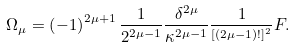<formula> <loc_0><loc_0><loc_500><loc_500>\Omega _ { \mu } = \left ( - 1 \right ) ^ { 2 \mu + 1 } \frac { 1 } { 2 ^ { 2 \mu - 1 } } \frac { \delta ^ { 2 \mu } } { \kappa ^ { 2 \mu - 1 } } \frac { 1 } { ^ { \left [ \left ( 2 \mu - 1 \right ) ! \right ] ^ { 2 } } } F .</formula> 